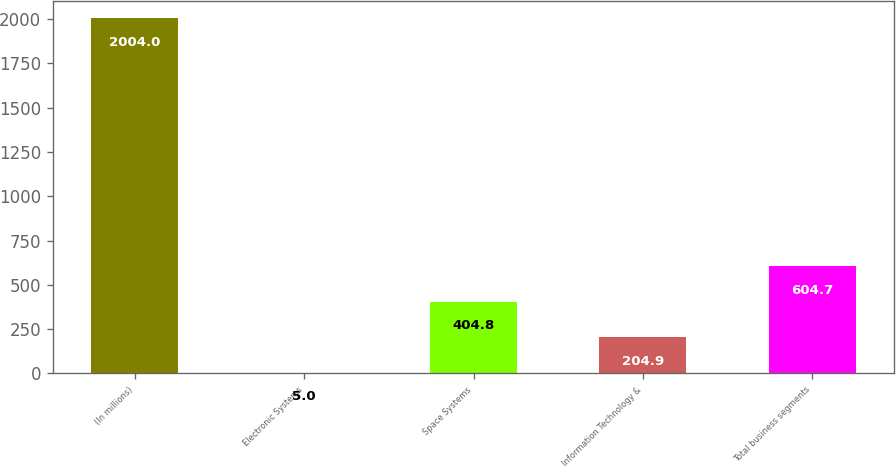<chart> <loc_0><loc_0><loc_500><loc_500><bar_chart><fcel>(In millions)<fcel>Electronic Systems<fcel>Space Systems<fcel>Information Technology &<fcel>Total business segments<nl><fcel>2004<fcel>5<fcel>404.8<fcel>204.9<fcel>604.7<nl></chart> 